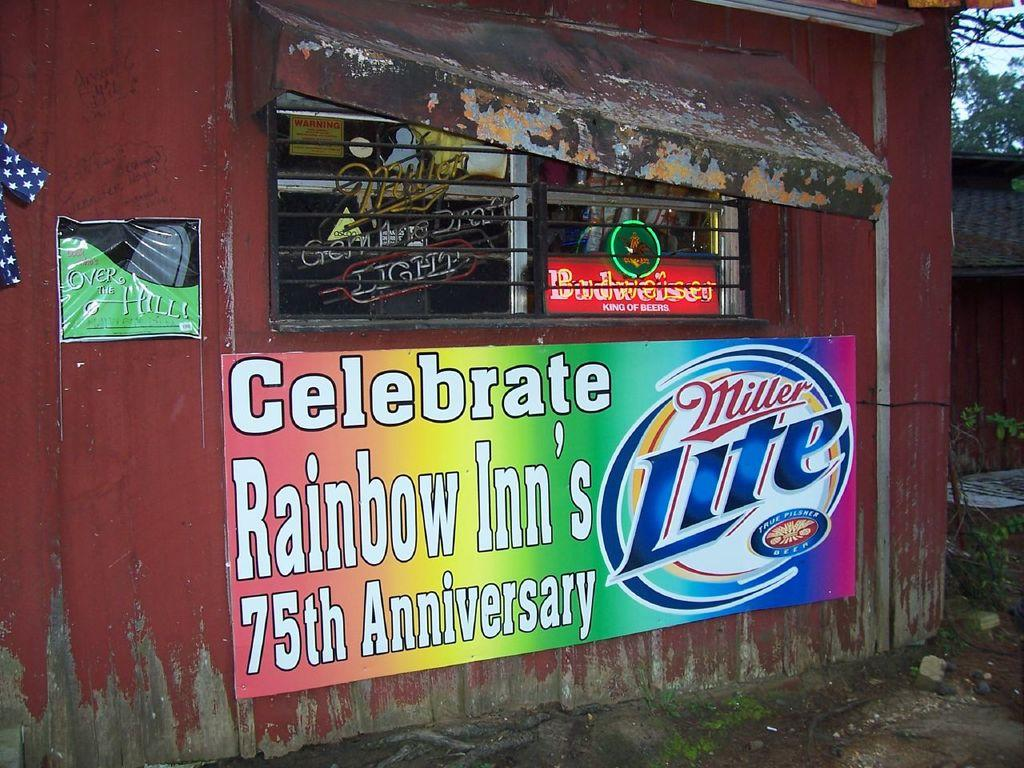<image>
Write a terse but informative summary of the picture. A red stand with the words celebrate rainbow inn's written on it. 